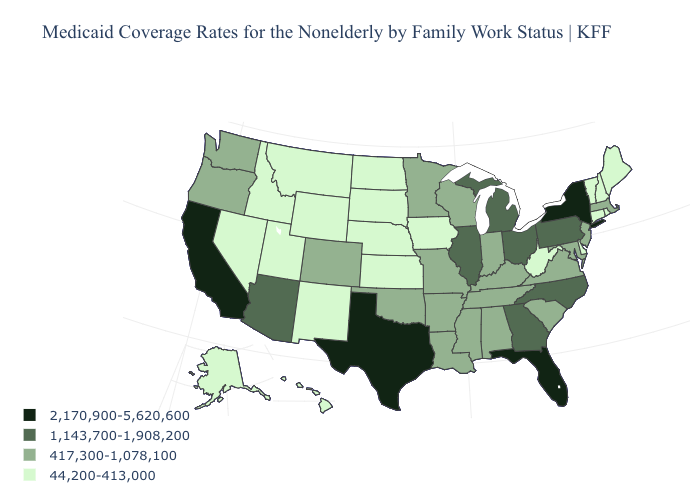Name the states that have a value in the range 44,200-413,000?
Be succinct. Alaska, Connecticut, Delaware, Hawaii, Idaho, Iowa, Kansas, Maine, Montana, Nebraska, Nevada, New Hampshire, New Mexico, North Dakota, Rhode Island, South Dakota, Utah, Vermont, West Virginia, Wyoming. Name the states that have a value in the range 1,143,700-1,908,200?
Keep it brief. Arizona, Georgia, Illinois, Michigan, North Carolina, Ohio, Pennsylvania. Does Washington have the lowest value in the West?
Answer briefly. No. What is the lowest value in states that border Wisconsin?
Answer briefly. 44,200-413,000. Name the states that have a value in the range 417,300-1,078,100?
Answer briefly. Alabama, Arkansas, Colorado, Indiana, Kentucky, Louisiana, Maryland, Massachusetts, Minnesota, Mississippi, Missouri, New Jersey, Oklahoma, Oregon, South Carolina, Tennessee, Virginia, Washington, Wisconsin. What is the lowest value in states that border Oregon?
Short answer required. 44,200-413,000. What is the lowest value in the MidWest?
Write a very short answer. 44,200-413,000. Is the legend a continuous bar?
Give a very brief answer. No. What is the lowest value in the South?
Quick response, please. 44,200-413,000. Which states have the lowest value in the MidWest?
Short answer required. Iowa, Kansas, Nebraska, North Dakota, South Dakota. Name the states that have a value in the range 417,300-1,078,100?
Be succinct. Alabama, Arkansas, Colorado, Indiana, Kentucky, Louisiana, Maryland, Massachusetts, Minnesota, Mississippi, Missouri, New Jersey, Oklahoma, Oregon, South Carolina, Tennessee, Virginia, Washington, Wisconsin. What is the value of Kansas?
Short answer required. 44,200-413,000. Name the states that have a value in the range 2,170,900-5,620,600?
Write a very short answer. California, Florida, New York, Texas. What is the highest value in states that border California?
Give a very brief answer. 1,143,700-1,908,200. Name the states that have a value in the range 44,200-413,000?
Quick response, please. Alaska, Connecticut, Delaware, Hawaii, Idaho, Iowa, Kansas, Maine, Montana, Nebraska, Nevada, New Hampshire, New Mexico, North Dakota, Rhode Island, South Dakota, Utah, Vermont, West Virginia, Wyoming. 